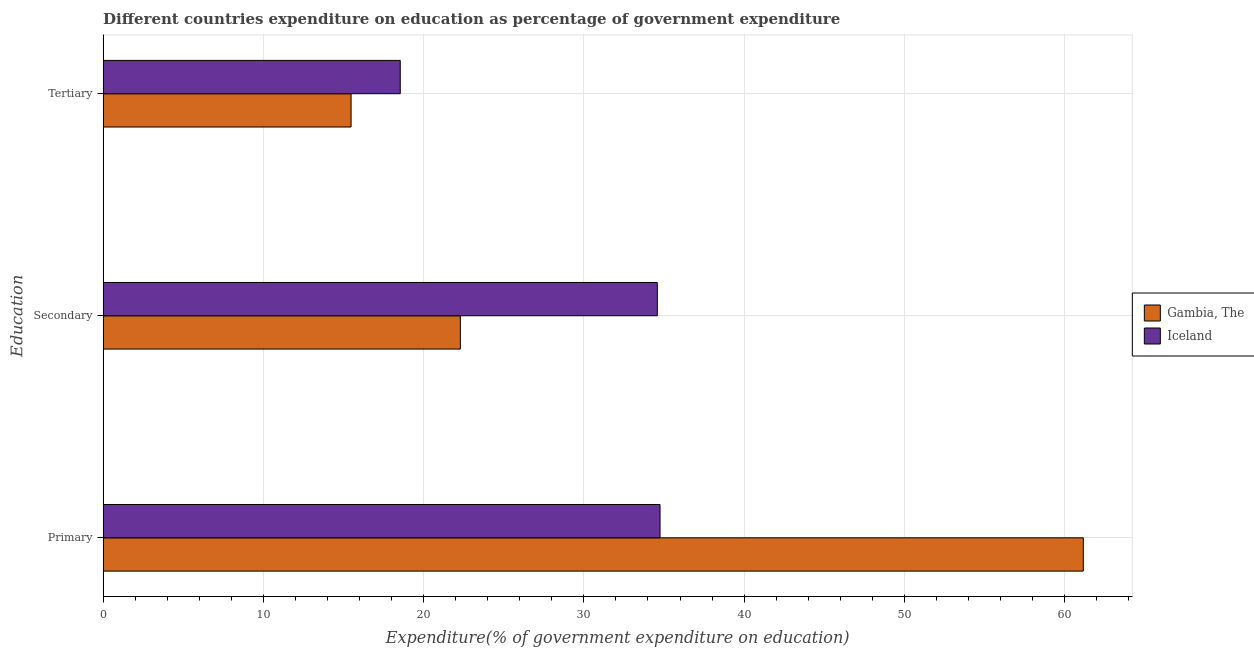How many groups of bars are there?
Give a very brief answer. 3. Are the number of bars per tick equal to the number of legend labels?
Provide a short and direct response. Yes. Are the number of bars on each tick of the Y-axis equal?
Offer a terse response. Yes. What is the label of the 3rd group of bars from the top?
Offer a terse response. Primary. What is the expenditure on secondary education in Iceland?
Provide a succinct answer. 34.58. Across all countries, what is the maximum expenditure on tertiary education?
Provide a short and direct response. 18.54. Across all countries, what is the minimum expenditure on tertiary education?
Give a very brief answer. 15.47. In which country was the expenditure on primary education maximum?
Give a very brief answer. Gambia, The. In which country was the expenditure on tertiary education minimum?
Your answer should be very brief. Gambia, The. What is the total expenditure on primary education in the graph?
Offer a very short reply. 95.92. What is the difference between the expenditure on primary education in Iceland and that in Gambia, The?
Provide a short and direct response. -26.41. What is the difference between the expenditure on primary education in Gambia, The and the expenditure on tertiary education in Iceland?
Provide a succinct answer. 42.62. What is the average expenditure on primary education per country?
Provide a succinct answer. 47.96. What is the difference between the expenditure on secondary education and expenditure on tertiary education in Gambia, The?
Provide a short and direct response. 6.82. In how many countries, is the expenditure on primary education greater than 42 %?
Your response must be concise. 1. What is the ratio of the expenditure on tertiary education in Gambia, The to that in Iceland?
Your answer should be compact. 0.83. Is the difference between the expenditure on secondary education in Iceland and Gambia, The greater than the difference between the expenditure on primary education in Iceland and Gambia, The?
Provide a succinct answer. Yes. What is the difference between the highest and the second highest expenditure on tertiary education?
Keep it short and to the point. 3.07. What is the difference between the highest and the lowest expenditure on primary education?
Provide a succinct answer. 26.41. In how many countries, is the expenditure on primary education greater than the average expenditure on primary education taken over all countries?
Offer a very short reply. 1. Is the sum of the expenditure on tertiary education in Iceland and Gambia, The greater than the maximum expenditure on primary education across all countries?
Your answer should be compact. No. What does the 1st bar from the top in Secondary represents?
Make the answer very short. Iceland. What does the 1st bar from the bottom in Tertiary represents?
Offer a very short reply. Gambia, The. Is it the case that in every country, the sum of the expenditure on primary education and expenditure on secondary education is greater than the expenditure on tertiary education?
Your answer should be compact. Yes. Are all the bars in the graph horizontal?
Offer a very short reply. Yes. What is the difference between two consecutive major ticks on the X-axis?
Offer a terse response. 10. Does the graph contain any zero values?
Your answer should be compact. No. How are the legend labels stacked?
Make the answer very short. Vertical. What is the title of the graph?
Offer a terse response. Different countries expenditure on education as percentage of government expenditure. What is the label or title of the X-axis?
Offer a very short reply. Expenditure(% of government expenditure on education). What is the label or title of the Y-axis?
Make the answer very short. Education. What is the Expenditure(% of government expenditure on education) of Gambia, The in Primary?
Offer a very short reply. 61.17. What is the Expenditure(% of government expenditure on education) of Iceland in Primary?
Offer a very short reply. 34.75. What is the Expenditure(% of government expenditure on education) of Gambia, The in Secondary?
Offer a terse response. 22.29. What is the Expenditure(% of government expenditure on education) in Iceland in Secondary?
Ensure brevity in your answer.  34.58. What is the Expenditure(% of government expenditure on education) in Gambia, The in Tertiary?
Keep it short and to the point. 15.47. What is the Expenditure(% of government expenditure on education) in Iceland in Tertiary?
Ensure brevity in your answer.  18.54. Across all Education, what is the maximum Expenditure(% of government expenditure on education) in Gambia, The?
Your answer should be very brief. 61.17. Across all Education, what is the maximum Expenditure(% of government expenditure on education) of Iceland?
Make the answer very short. 34.75. Across all Education, what is the minimum Expenditure(% of government expenditure on education) in Gambia, The?
Keep it short and to the point. 15.47. Across all Education, what is the minimum Expenditure(% of government expenditure on education) in Iceland?
Make the answer very short. 18.54. What is the total Expenditure(% of government expenditure on education) of Gambia, The in the graph?
Provide a short and direct response. 98.93. What is the total Expenditure(% of government expenditure on education) of Iceland in the graph?
Keep it short and to the point. 87.87. What is the difference between the Expenditure(% of government expenditure on education) of Gambia, The in Primary and that in Secondary?
Ensure brevity in your answer.  38.87. What is the difference between the Expenditure(% of government expenditure on education) in Iceland in Primary and that in Secondary?
Offer a terse response. 0.17. What is the difference between the Expenditure(% of government expenditure on education) of Gambia, The in Primary and that in Tertiary?
Make the answer very short. 45.69. What is the difference between the Expenditure(% of government expenditure on education) of Iceland in Primary and that in Tertiary?
Your answer should be very brief. 16.21. What is the difference between the Expenditure(% of government expenditure on education) in Gambia, The in Secondary and that in Tertiary?
Give a very brief answer. 6.82. What is the difference between the Expenditure(% of government expenditure on education) of Iceland in Secondary and that in Tertiary?
Give a very brief answer. 16.04. What is the difference between the Expenditure(% of government expenditure on education) of Gambia, The in Primary and the Expenditure(% of government expenditure on education) of Iceland in Secondary?
Your response must be concise. 26.58. What is the difference between the Expenditure(% of government expenditure on education) in Gambia, The in Primary and the Expenditure(% of government expenditure on education) in Iceland in Tertiary?
Give a very brief answer. 42.62. What is the difference between the Expenditure(% of government expenditure on education) in Gambia, The in Secondary and the Expenditure(% of government expenditure on education) in Iceland in Tertiary?
Offer a very short reply. 3.75. What is the average Expenditure(% of government expenditure on education) of Gambia, The per Education?
Make the answer very short. 32.98. What is the average Expenditure(% of government expenditure on education) in Iceland per Education?
Provide a short and direct response. 29.29. What is the difference between the Expenditure(% of government expenditure on education) of Gambia, The and Expenditure(% of government expenditure on education) of Iceland in Primary?
Your answer should be very brief. 26.41. What is the difference between the Expenditure(% of government expenditure on education) of Gambia, The and Expenditure(% of government expenditure on education) of Iceland in Secondary?
Ensure brevity in your answer.  -12.29. What is the difference between the Expenditure(% of government expenditure on education) of Gambia, The and Expenditure(% of government expenditure on education) of Iceland in Tertiary?
Keep it short and to the point. -3.07. What is the ratio of the Expenditure(% of government expenditure on education) of Gambia, The in Primary to that in Secondary?
Your answer should be very brief. 2.74. What is the ratio of the Expenditure(% of government expenditure on education) in Gambia, The in Primary to that in Tertiary?
Give a very brief answer. 3.95. What is the ratio of the Expenditure(% of government expenditure on education) of Iceland in Primary to that in Tertiary?
Make the answer very short. 1.87. What is the ratio of the Expenditure(% of government expenditure on education) of Gambia, The in Secondary to that in Tertiary?
Make the answer very short. 1.44. What is the ratio of the Expenditure(% of government expenditure on education) in Iceland in Secondary to that in Tertiary?
Your answer should be very brief. 1.87. What is the difference between the highest and the second highest Expenditure(% of government expenditure on education) of Gambia, The?
Keep it short and to the point. 38.87. What is the difference between the highest and the second highest Expenditure(% of government expenditure on education) in Iceland?
Your response must be concise. 0.17. What is the difference between the highest and the lowest Expenditure(% of government expenditure on education) of Gambia, The?
Your answer should be very brief. 45.69. What is the difference between the highest and the lowest Expenditure(% of government expenditure on education) in Iceland?
Offer a very short reply. 16.21. 